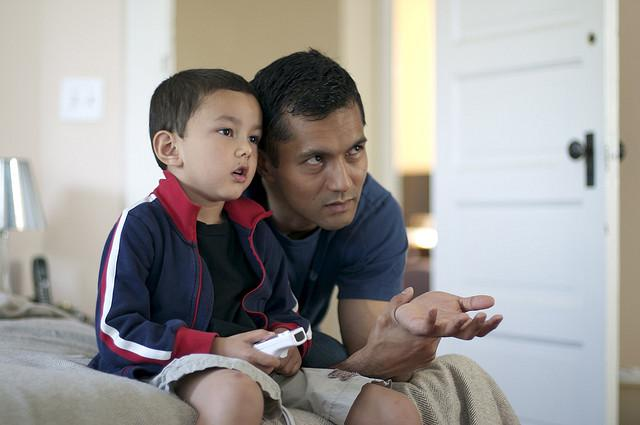What is the man helping the young boy do?

Choices:
A) play games
B) learn math
C) count
D) finish puzzle play games 